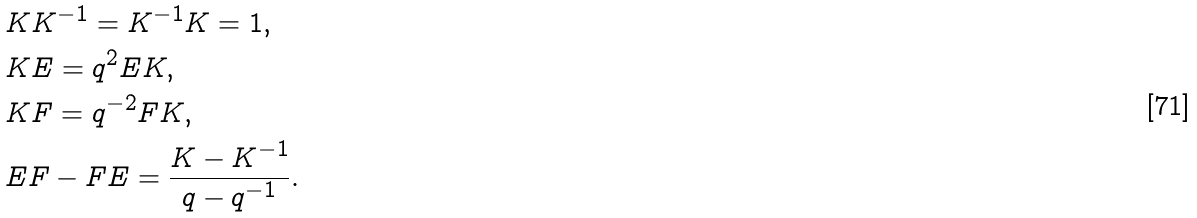<formula> <loc_0><loc_0><loc_500><loc_500>& K K ^ { - 1 } = K ^ { - 1 } K = 1 , \\ & K E = q ^ { 2 } E K , \\ & K F = q ^ { - 2 } F K , \\ & E F - F E = \frac { K - K ^ { - 1 } } { q - q ^ { - 1 } } .</formula> 